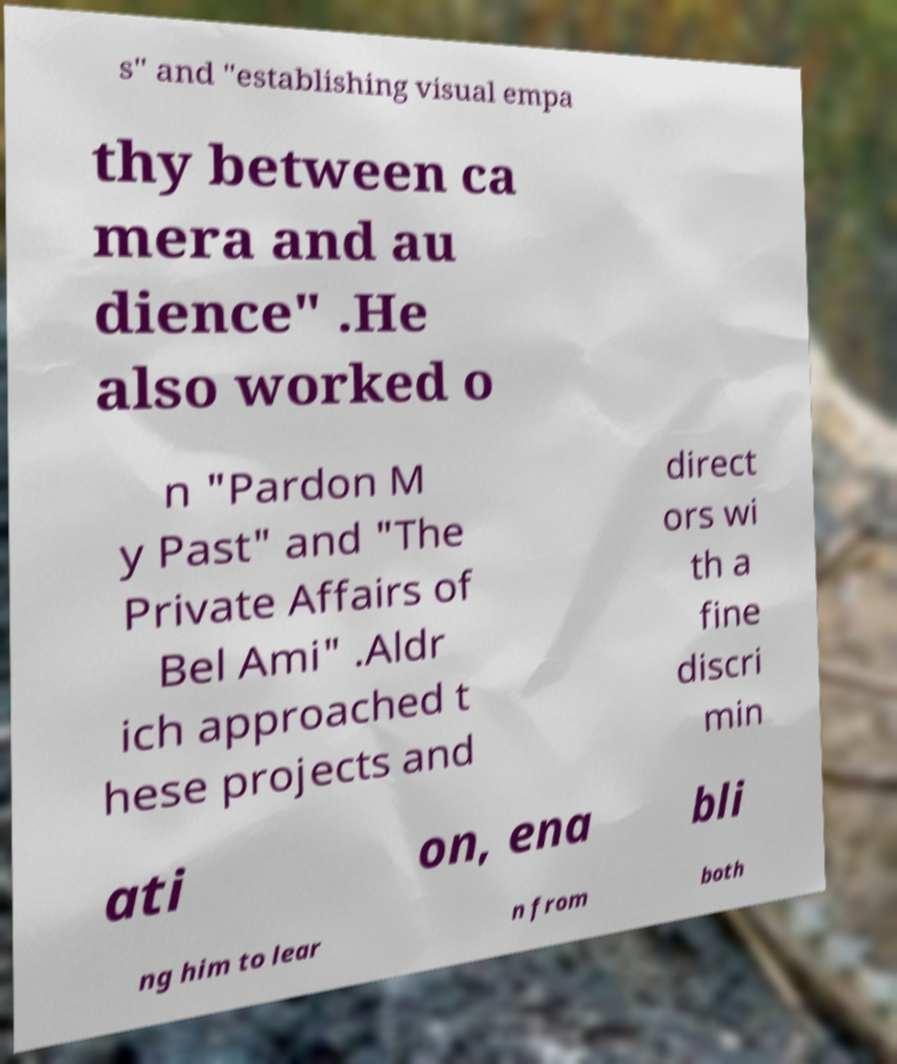Please read and relay the text visible in this image. What does it say? s" and "establishing visual empa thy between ca mera and au dience" .He also worked o n "Pardon M y Past" and "The Private Affairs of Bel Ami" .Aldr ich approached t hese projects and direct ors wi th a fine discri min ati on, ena bli ng him to lear n from both 